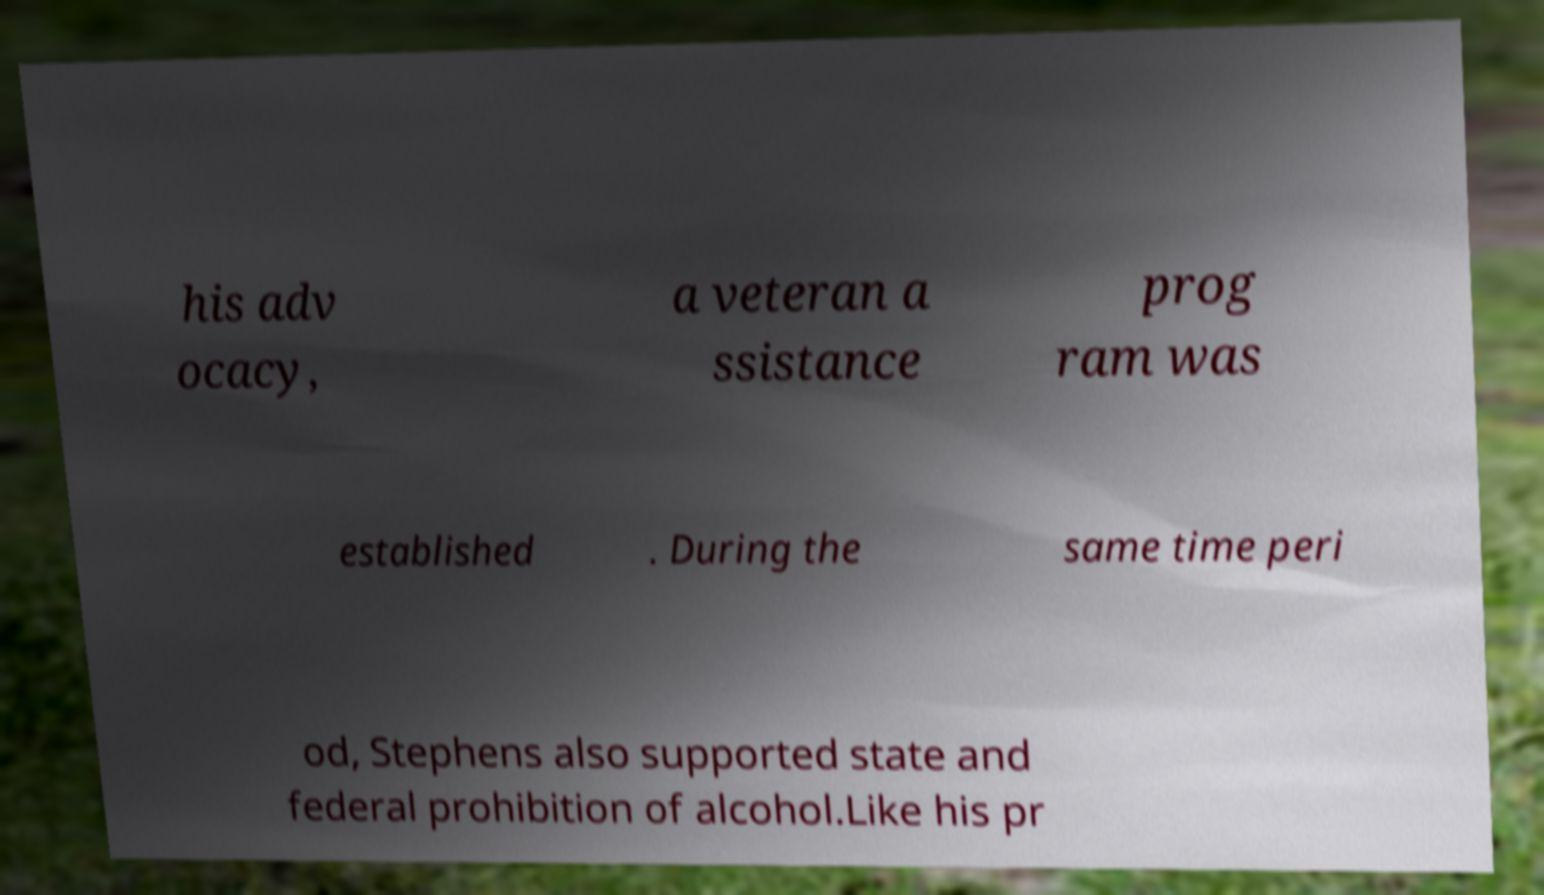There's text embedded in this image that I need extracted. Can you transcribe it verbatim? his adv ocacy, a veteran a ssistance prog ram was established . During the same time peri od, Stephens also supported state and federal prohibition of alcohol.Like his pr 